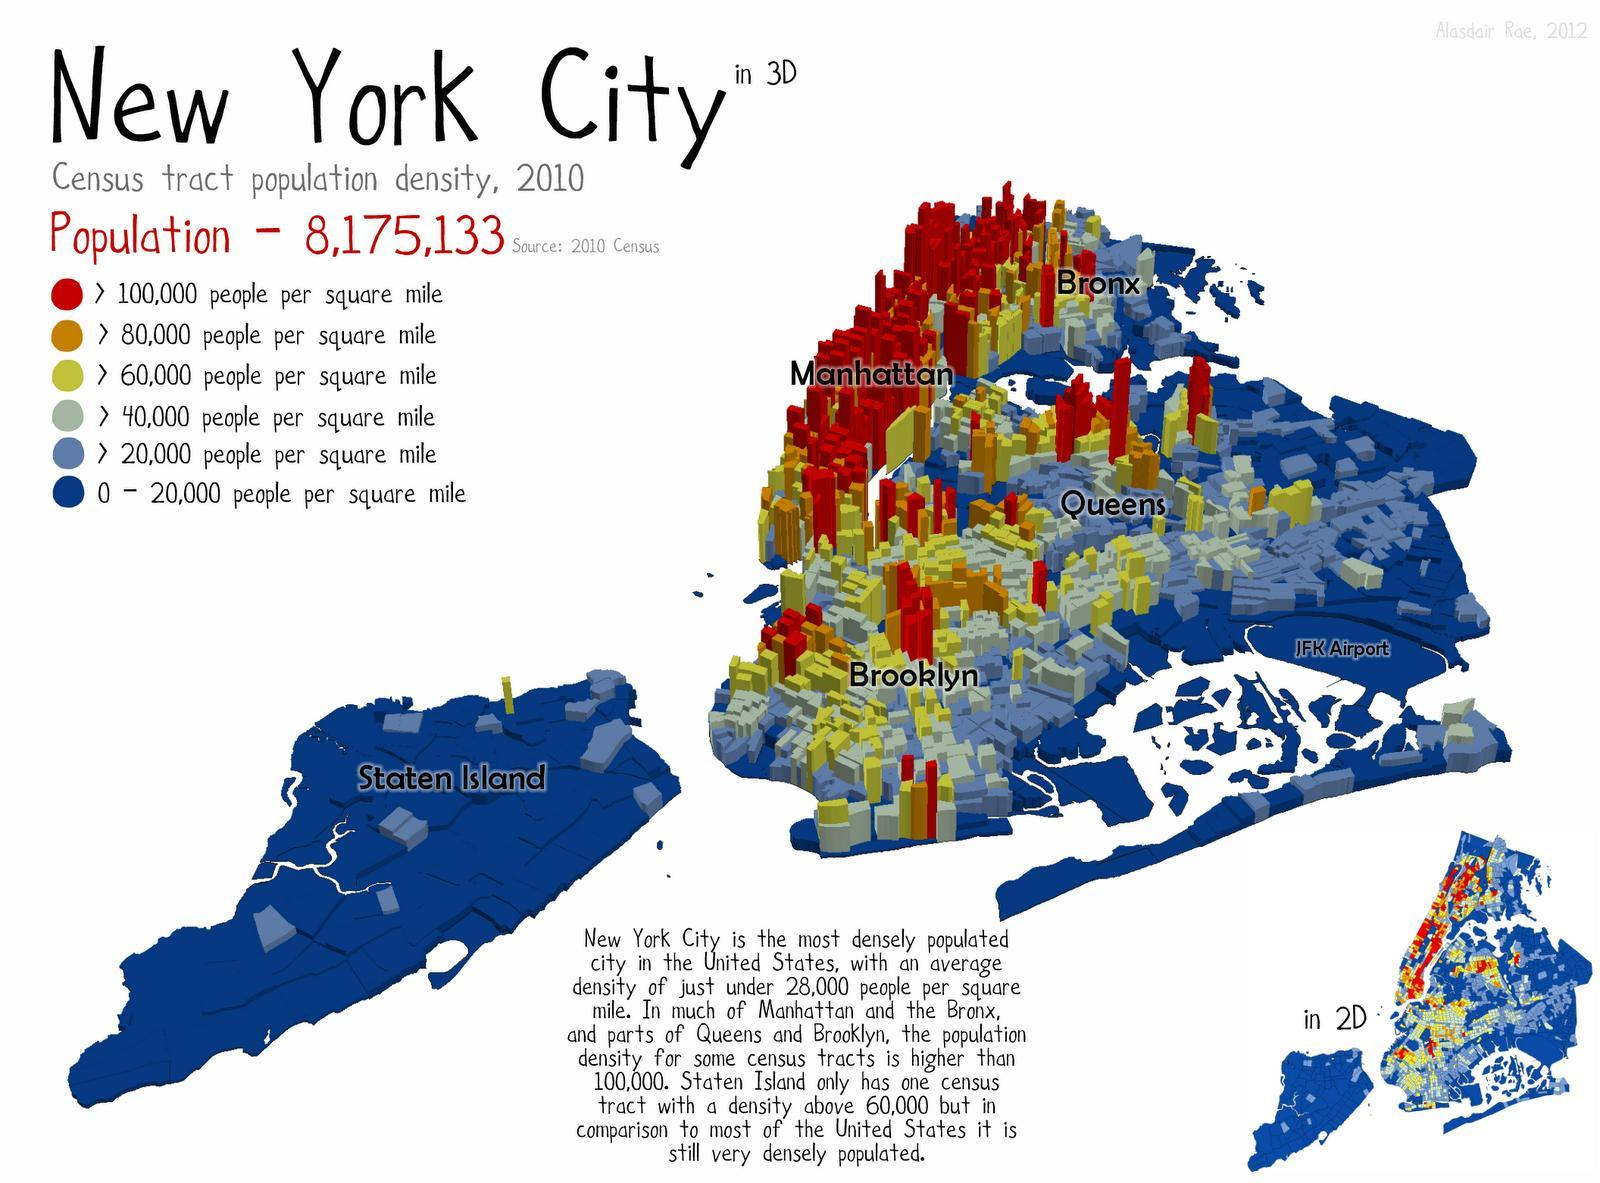How many categories of the population mentioned in this infographic?
Answer the question with a short phrase. 6 